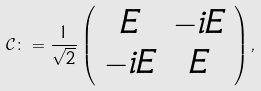<formula> <loc_0><loc_0><loc_500><loc_500>\mathcal { C } \colon = \frac { 1 } { \sqrt { 2 } } \left ( \begin{array} { c c } E & - i E \\ - i E & E \end{array} \right ) ,</formula> 